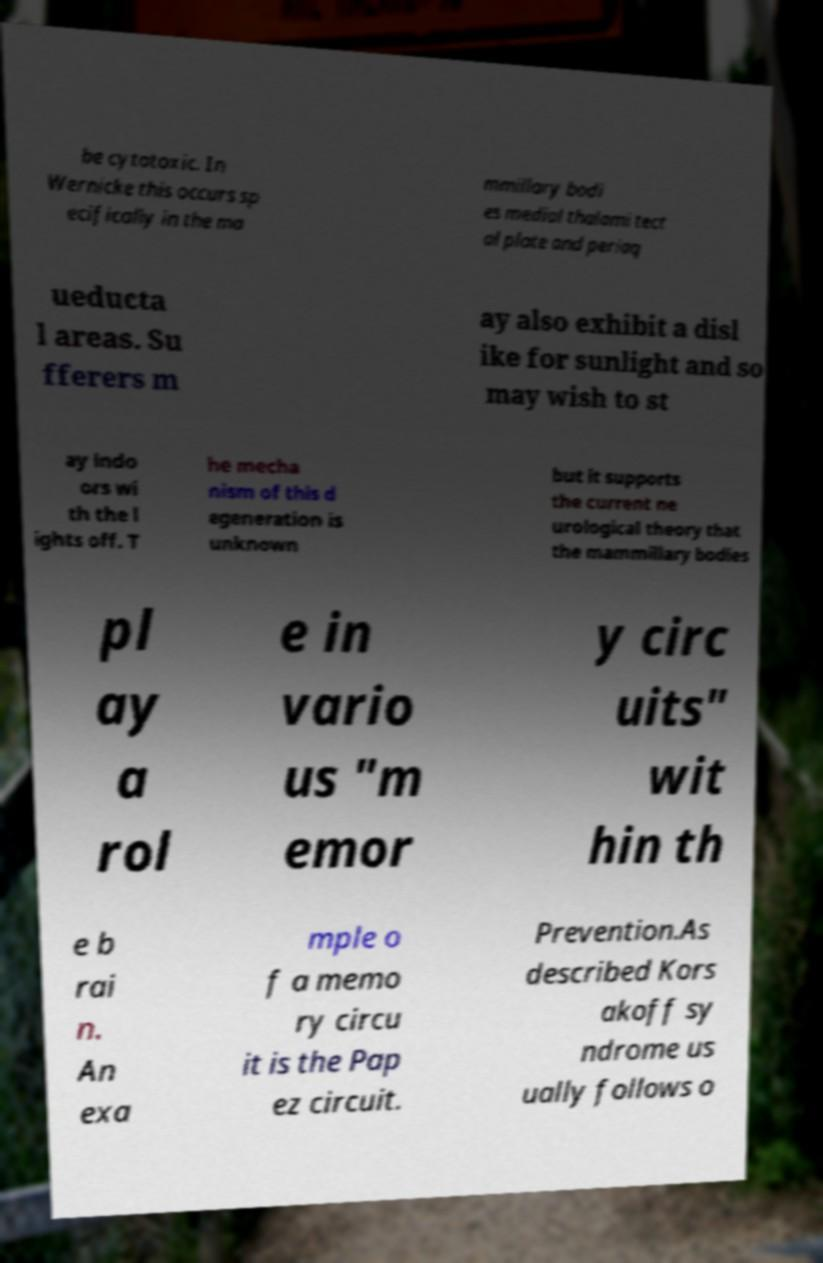Please read and relay the text visible in this image. What does it say? be cytotoxic. In Wernicke this occurs sp ecifically in the ma mmillary bodi es medial thalami tect al plate and periaq ueducta l areas. Su fferers m ay also exhibit a disl ike for sunlight and so may wish to st ay indo ors wi th the l ights off. T he mecha nism of this d egeneration is unknown but it supports the current ne urological theory that the mammillary bodies pl ay a rol e in vario us "m emor y circ uits" wit hin th e b rai n. An exa mple o f a memo ry circu it is the Pap ez circuit. Prevention.As described Kors akoff sy ndrome us ually follows o 